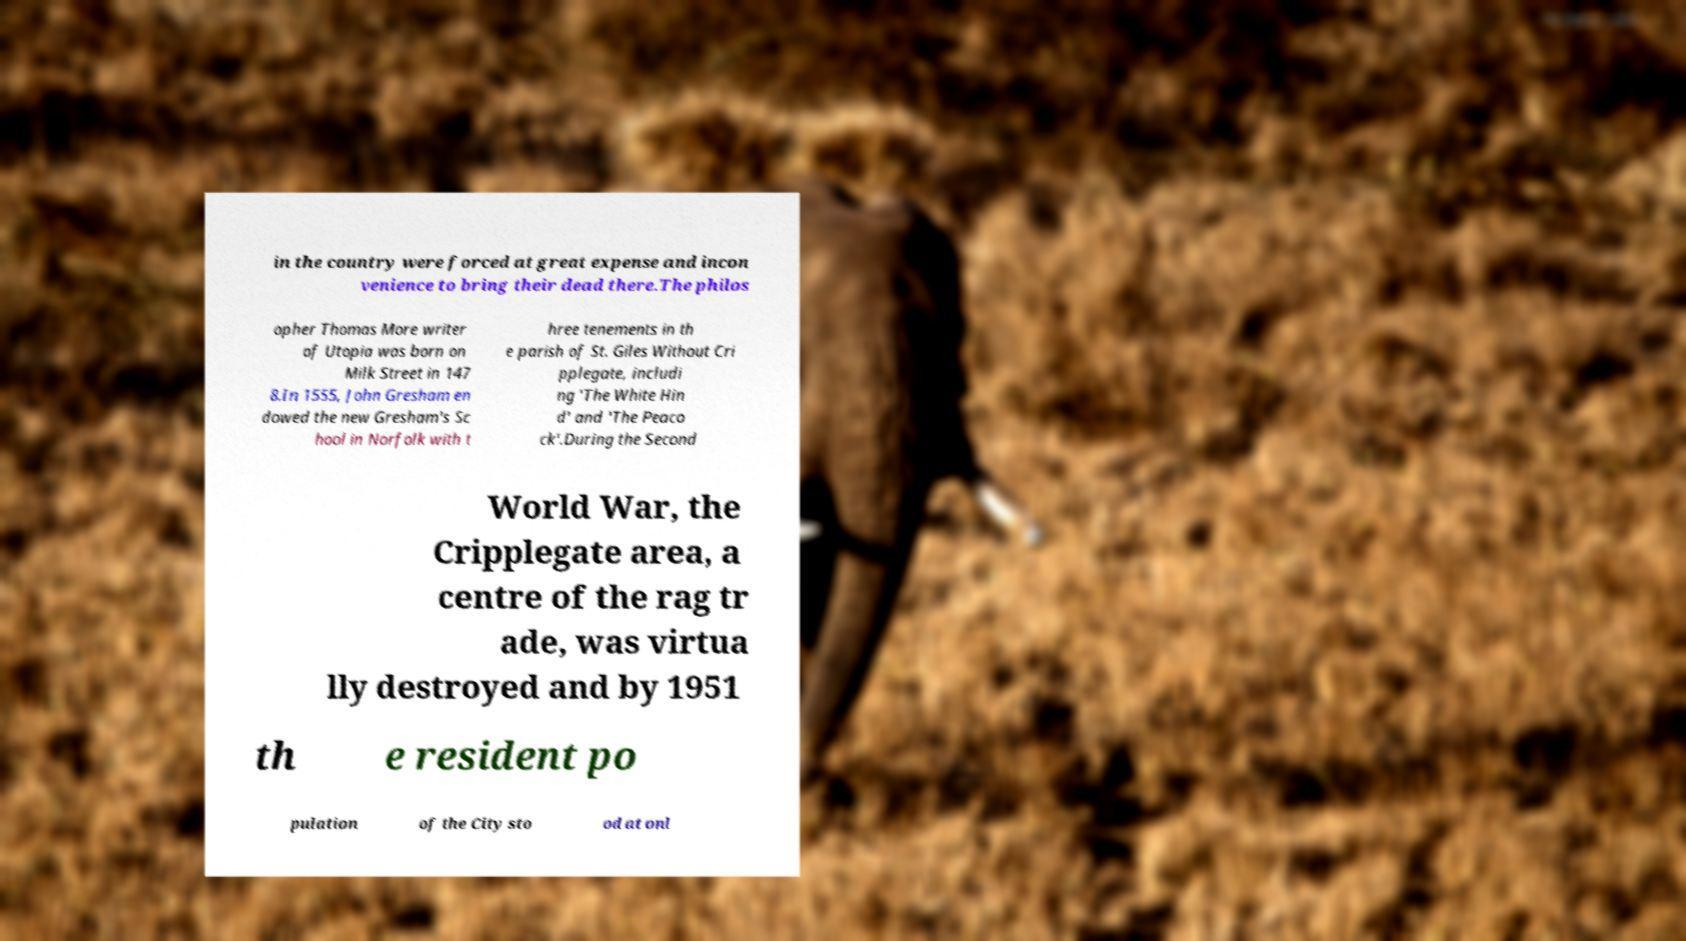For documentation purposes, I need the text within this image transcribed. Could you provide that? in the country were forced at great expense and incon venience to bring their dead there.The philos opher Thomas More writer of Utopia was born on Milk Street in 147 8.In 1555, John Gresham en dowed the new Gresham's Sc hool in Norfolk with t hree tenements in th e parish of St. Giles Without Cri pplegate, includi ng 'The White Hin d' and 'The Peaco ck'.During the Second World War, the Cripplegate area, a centre of the rag tr ade, was virtua lly destroyed and by 1951 th e resident po pulation of the City sto od at onl 